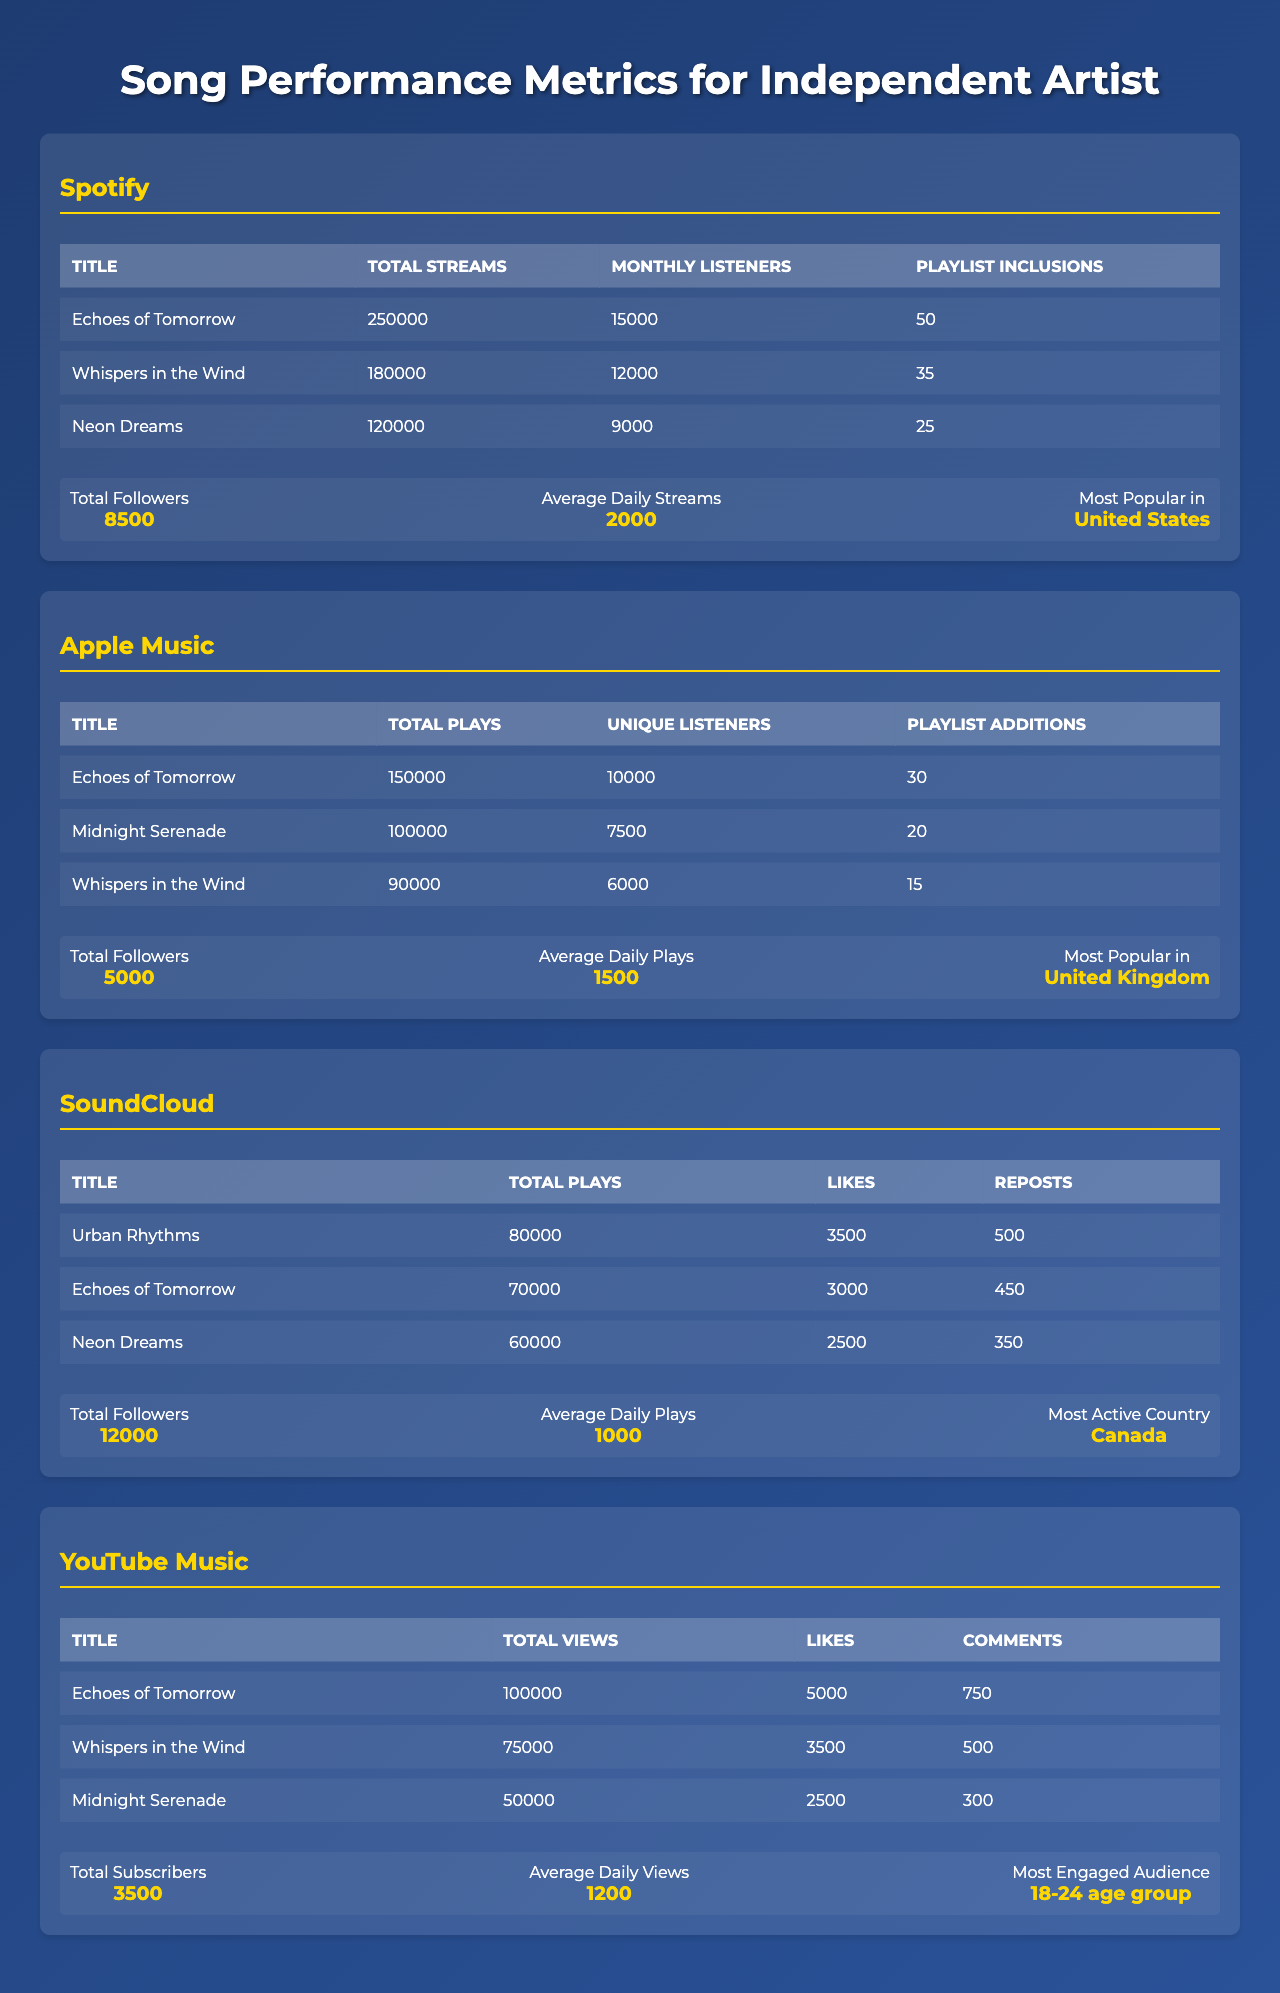What's the total number of streams for "Echoes of Tomorrow" on Spotify? On Spotify, "Echoes of Tomorrow" has a total of 250,000 streams, as shown in the table.
Answer: 250000 Which song has the most unique listeners on Apple Music? "Echoes of Tomorrow" is listed with 10,000 unique listeners, more than the other songs.
Answer: Echoes of Tomorrow What is the average daily streams across all platforms for the artist? The average daily streams on Spotify is 2000, on Apple Music is 1500, on SoundCloud is 1000, and on YouTube Music is 1200, summing up to 6700. Dividing by 4 platforms gives an average of 1675.
Answer: 1675 How many playlist inclusions does "Whispers in the Wind" have on Spotify? It has 35 playlist inclusions, as per the Spotify section of the table.
Answer: 35 Is "Midnight Serenade" included in the top performing songs on Spotify? No, "Midnight Serenade" is not listed among the top performing songs on Spotify, as the table indicates.
Answer: No What is the total number of followers across all platforms? The total followers are 8500 (Spotify) + 5000 (Apple Music) + 12000 (SoundCloud) + 3500 (YouTube Music) = 30500 total followers.
Answer: 30500 Which platform has the highest average daily plays? SoundCloud has the highest average daily plays with 1000, compared to 2000 on Spotify, 1500 on Apple Music, and 1200 on YouTube Music.
Answer: SoundCloud Calculate the difference in total views between "Echoes of Tomorrow" and "Whispers in the Wind" on YouTube Music. "Echoes of Tomorrow" has 100,000 views, while "Whispers in the Wind" has 75,000 views. The difference is 100,000 - 75,000 = 25,000 views.
Answer: 25000 Which song has the most total plays on SoundCloud and how many? "Urban Rhythms" has the highest total plays on SoundCloud with 80,000 plays, as indicated in the table.
Answer: Urban Rhythms, 80000 What is the overall most popular song across all platforms? "Echoes of Tomorrow" appears in the top performing lists across Spotify, Apple Music, and YouTube Music, confirming it as the most popular song.
Answer: Echoes of Tomorrow 